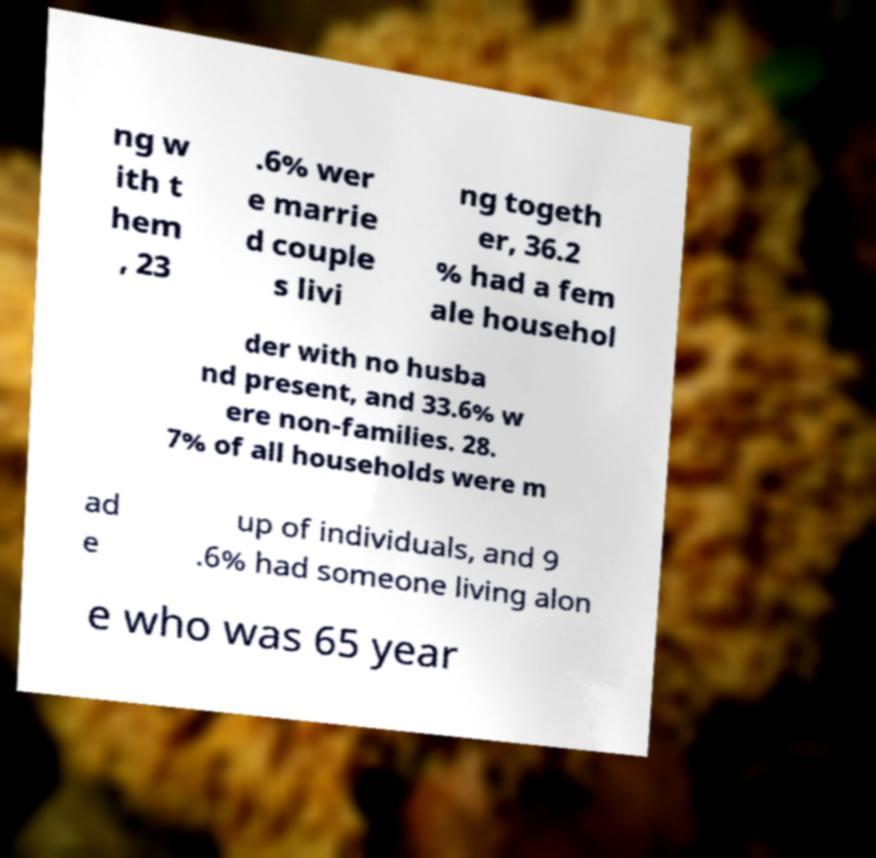For documentation purposes, I need the text within this image transcribed. Could you provide that? ng w ith t hem , 23 .6% wer e marrie d couple s livi ng togeth er, 36.2 % had a fem ale househol der with no husba nd present, and 33.6% w ere non-families. 28. 7% of all households were m ad e up of individuals, and 9 .6% had someone living alon e who was 65 year 